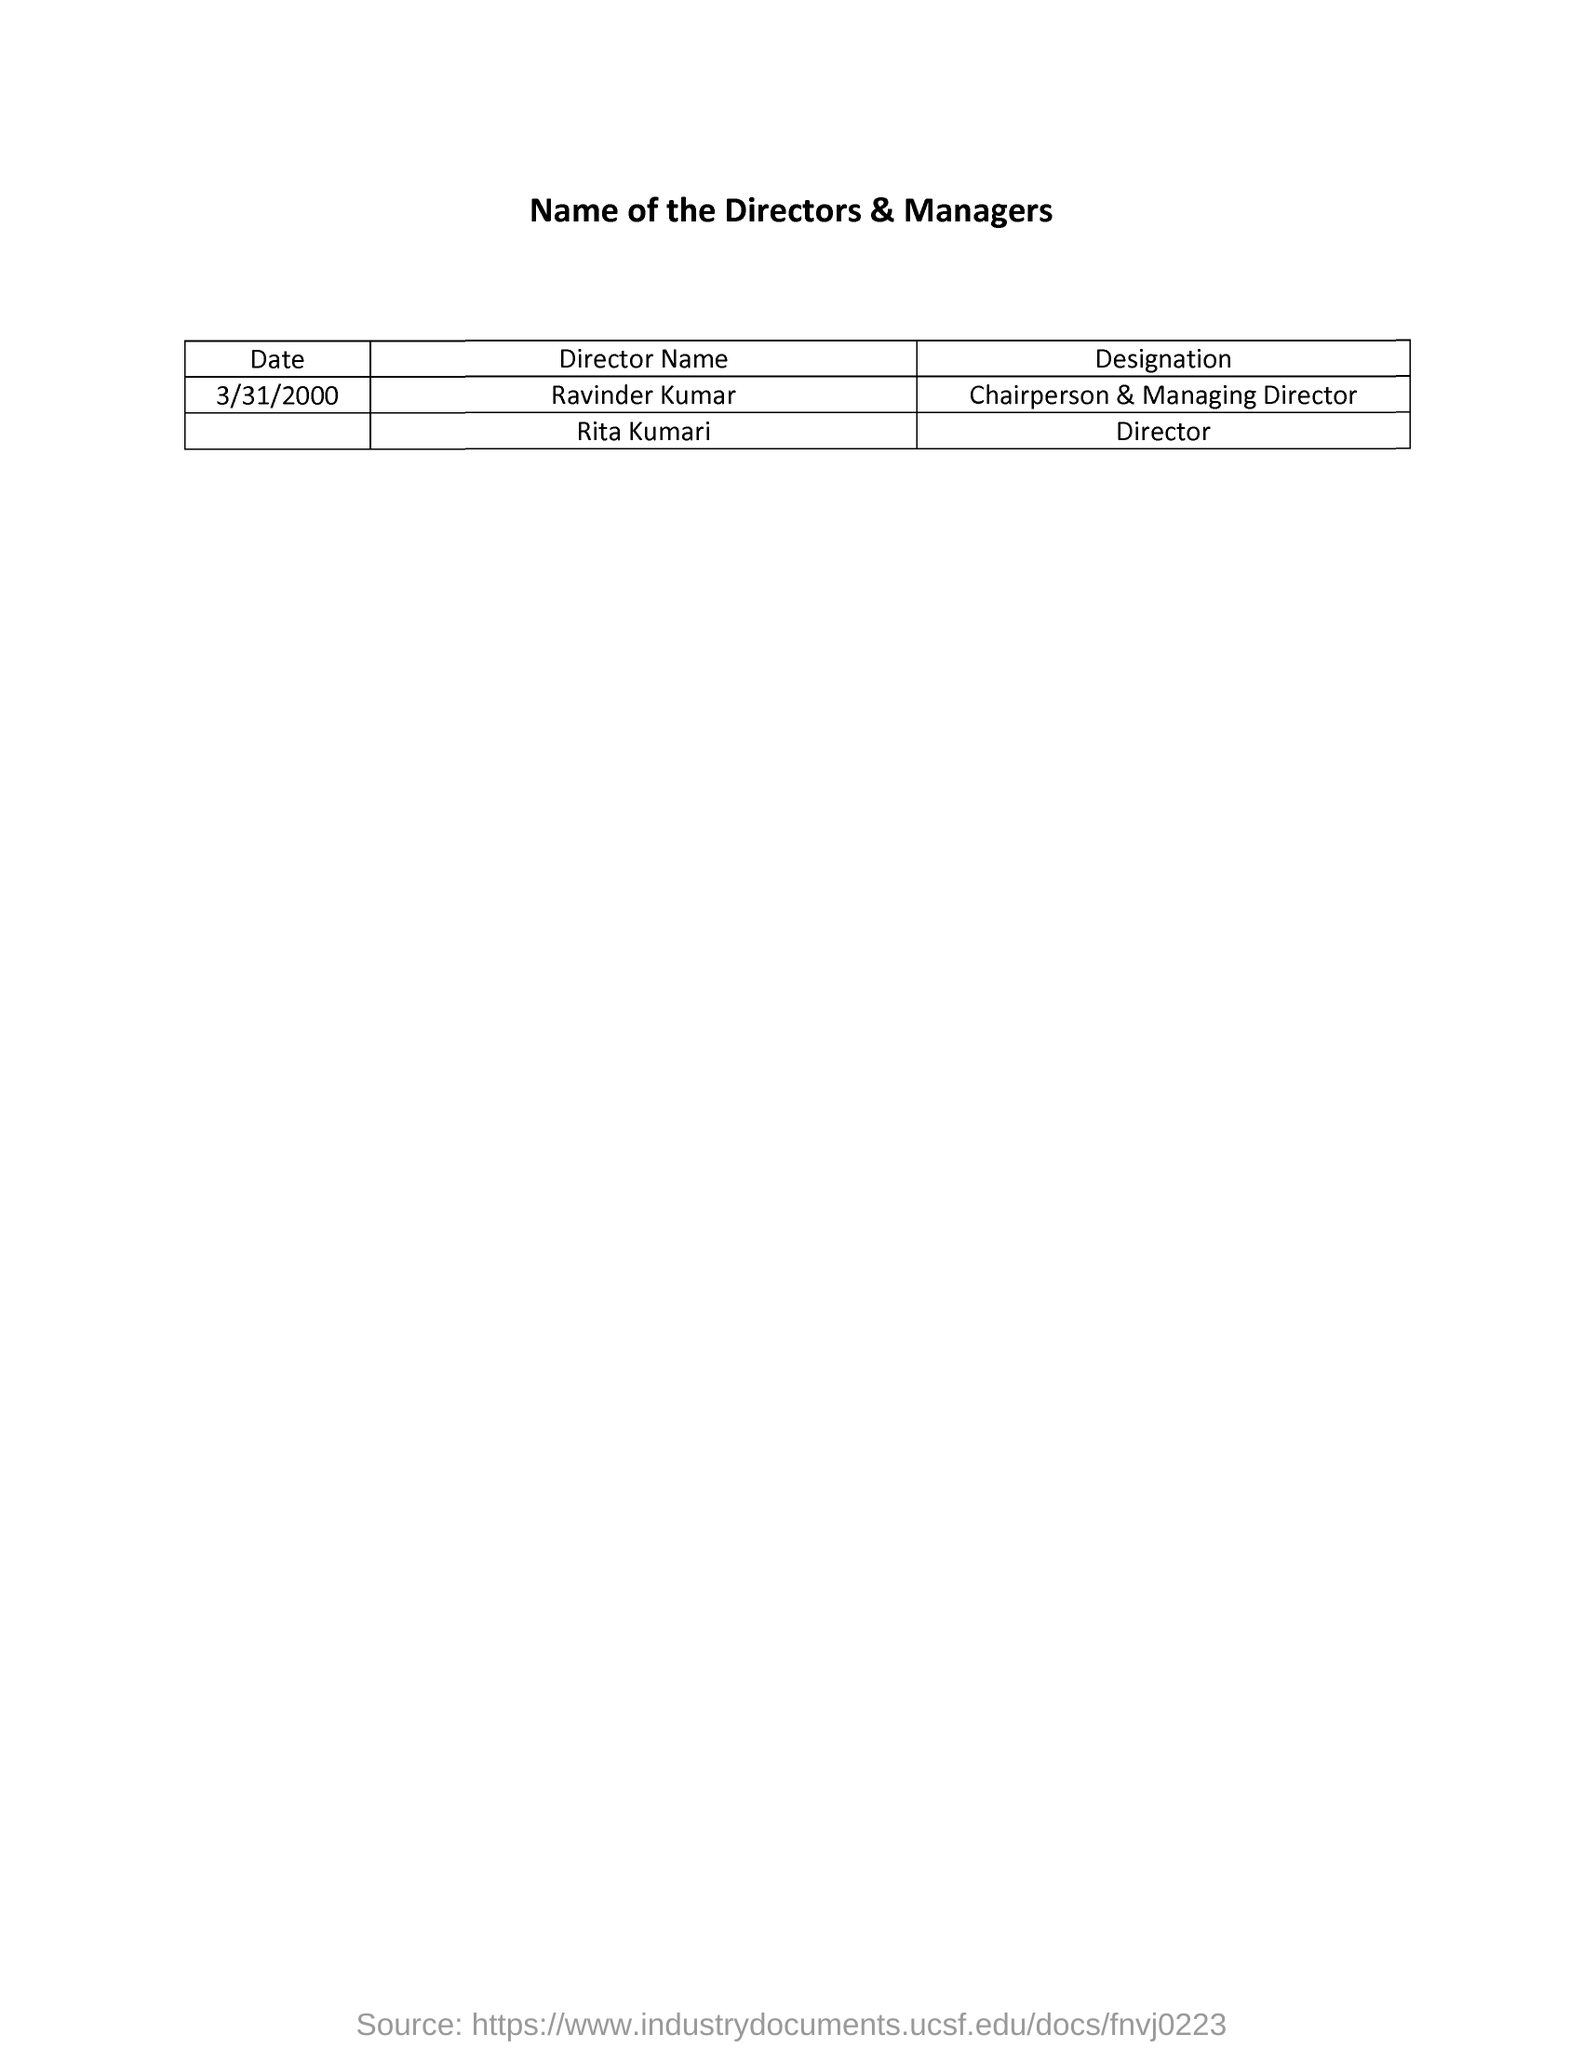Mention a couple of crucial points in this snapshot. The date mentioned in the list is March 31, 2000. The name of the Chairperson and Managing Director is Ravinder Kumar. Rita Kumari is a director. 